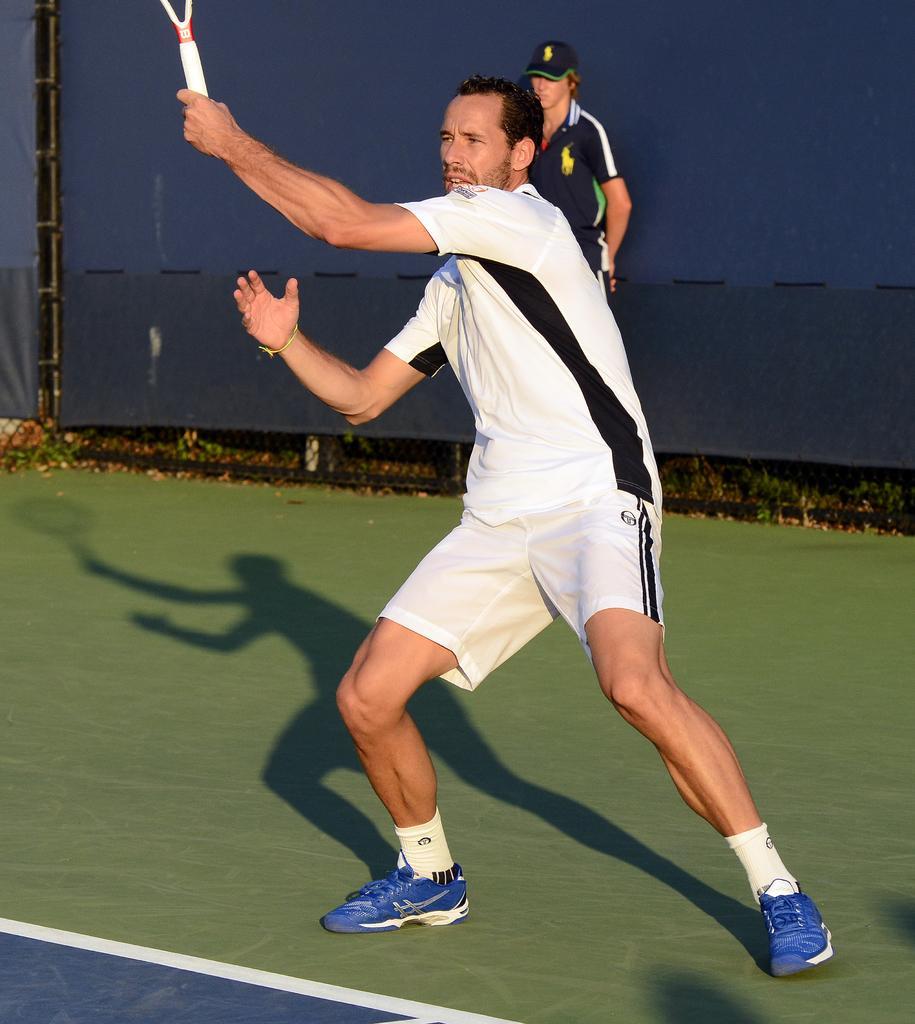Please provide a concise description of this image. In this image I can see a man is standing and also I can see he is wearing sportswear. In the background I can see one more person wearing a cap. 